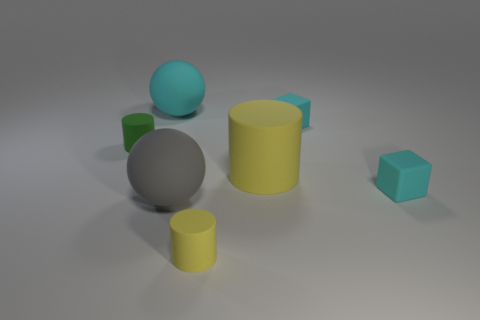Add 2 small cylinders. How many objects exist? 9 Subtract all cylinders. How many objects are left? 4 Add 4 green objects. How many green objects exist? 5 Subtract 0 blue blocks. How many objects are left? 7 Subtract all small red shiny cylinders. Subtract all tiny cyan things. How many objects are left? 5 Add 4 yellow cylinders. How many yellow cylinders are left? 6 